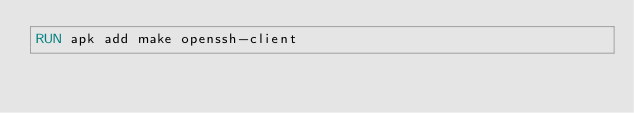<code> <loc_0><loc_0><loc_500><loc_500><_Dockerfile_>RUN apk add make openssh-client
</code> 